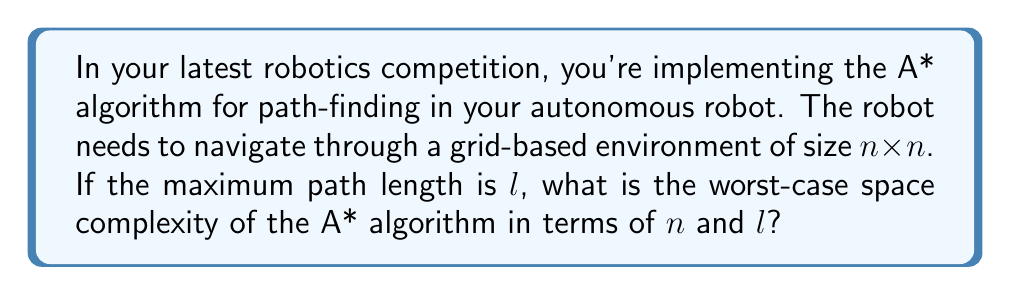Show me your answer to this math problem. Let's break this down step-by-step:

1) The A* algorithm uses three main data structures:
   - Open list: Contains nodes to be evaluated
   - Closed list: Contains nodes already evaluated
   - Path: Stores the current best path

2) In the worst case, the open list and closed list might contain all nodes in the grid. The number of nodes in an $n \times n$ grid is $n^2$.

3) For each node, we need to store:
   - Its position: $O(1)$ space
   - Its $g$ score (cost from start): $O(1)$ space
   - Its $h$ score (heuristic estimate to goal): $O(1)$ space
   - Its $f$ score ($g + h$): $O(1)$ space
   - A pointer to its parent node: $O(1)$ space

4) Therefore, each node requires $O(1)$ space, and we have $O(n^2)$ nodes in total.

5) The path being constructed can have a maximum length of $l$. Each step in the path requires $O(1)$ space to store.

6) Combining these factors, we get:
   $$O(n^2) + O(n^2) + O(l) = O(n^2 + l)$$

   The first $O(n^2)$ is for the open list, the second for the closed list, and $O(l)$ for the path.

7) In the worst case, where the path might need to visit every cell (e.g., in a maze-like environment), $l$ could be as large as $n^2$. In this case, the space complexity simplifies to $O(n^2)$.

8) However, in many practical scenarios, $l$ is often much smaller than $n^2$, so it's useful to keep both terms.
Answer: The worst-case space complexity of the A* algorithm for path-finding in an $n \times n$ grid with maximum path length $l$ is $O(n^2 + l)$. 